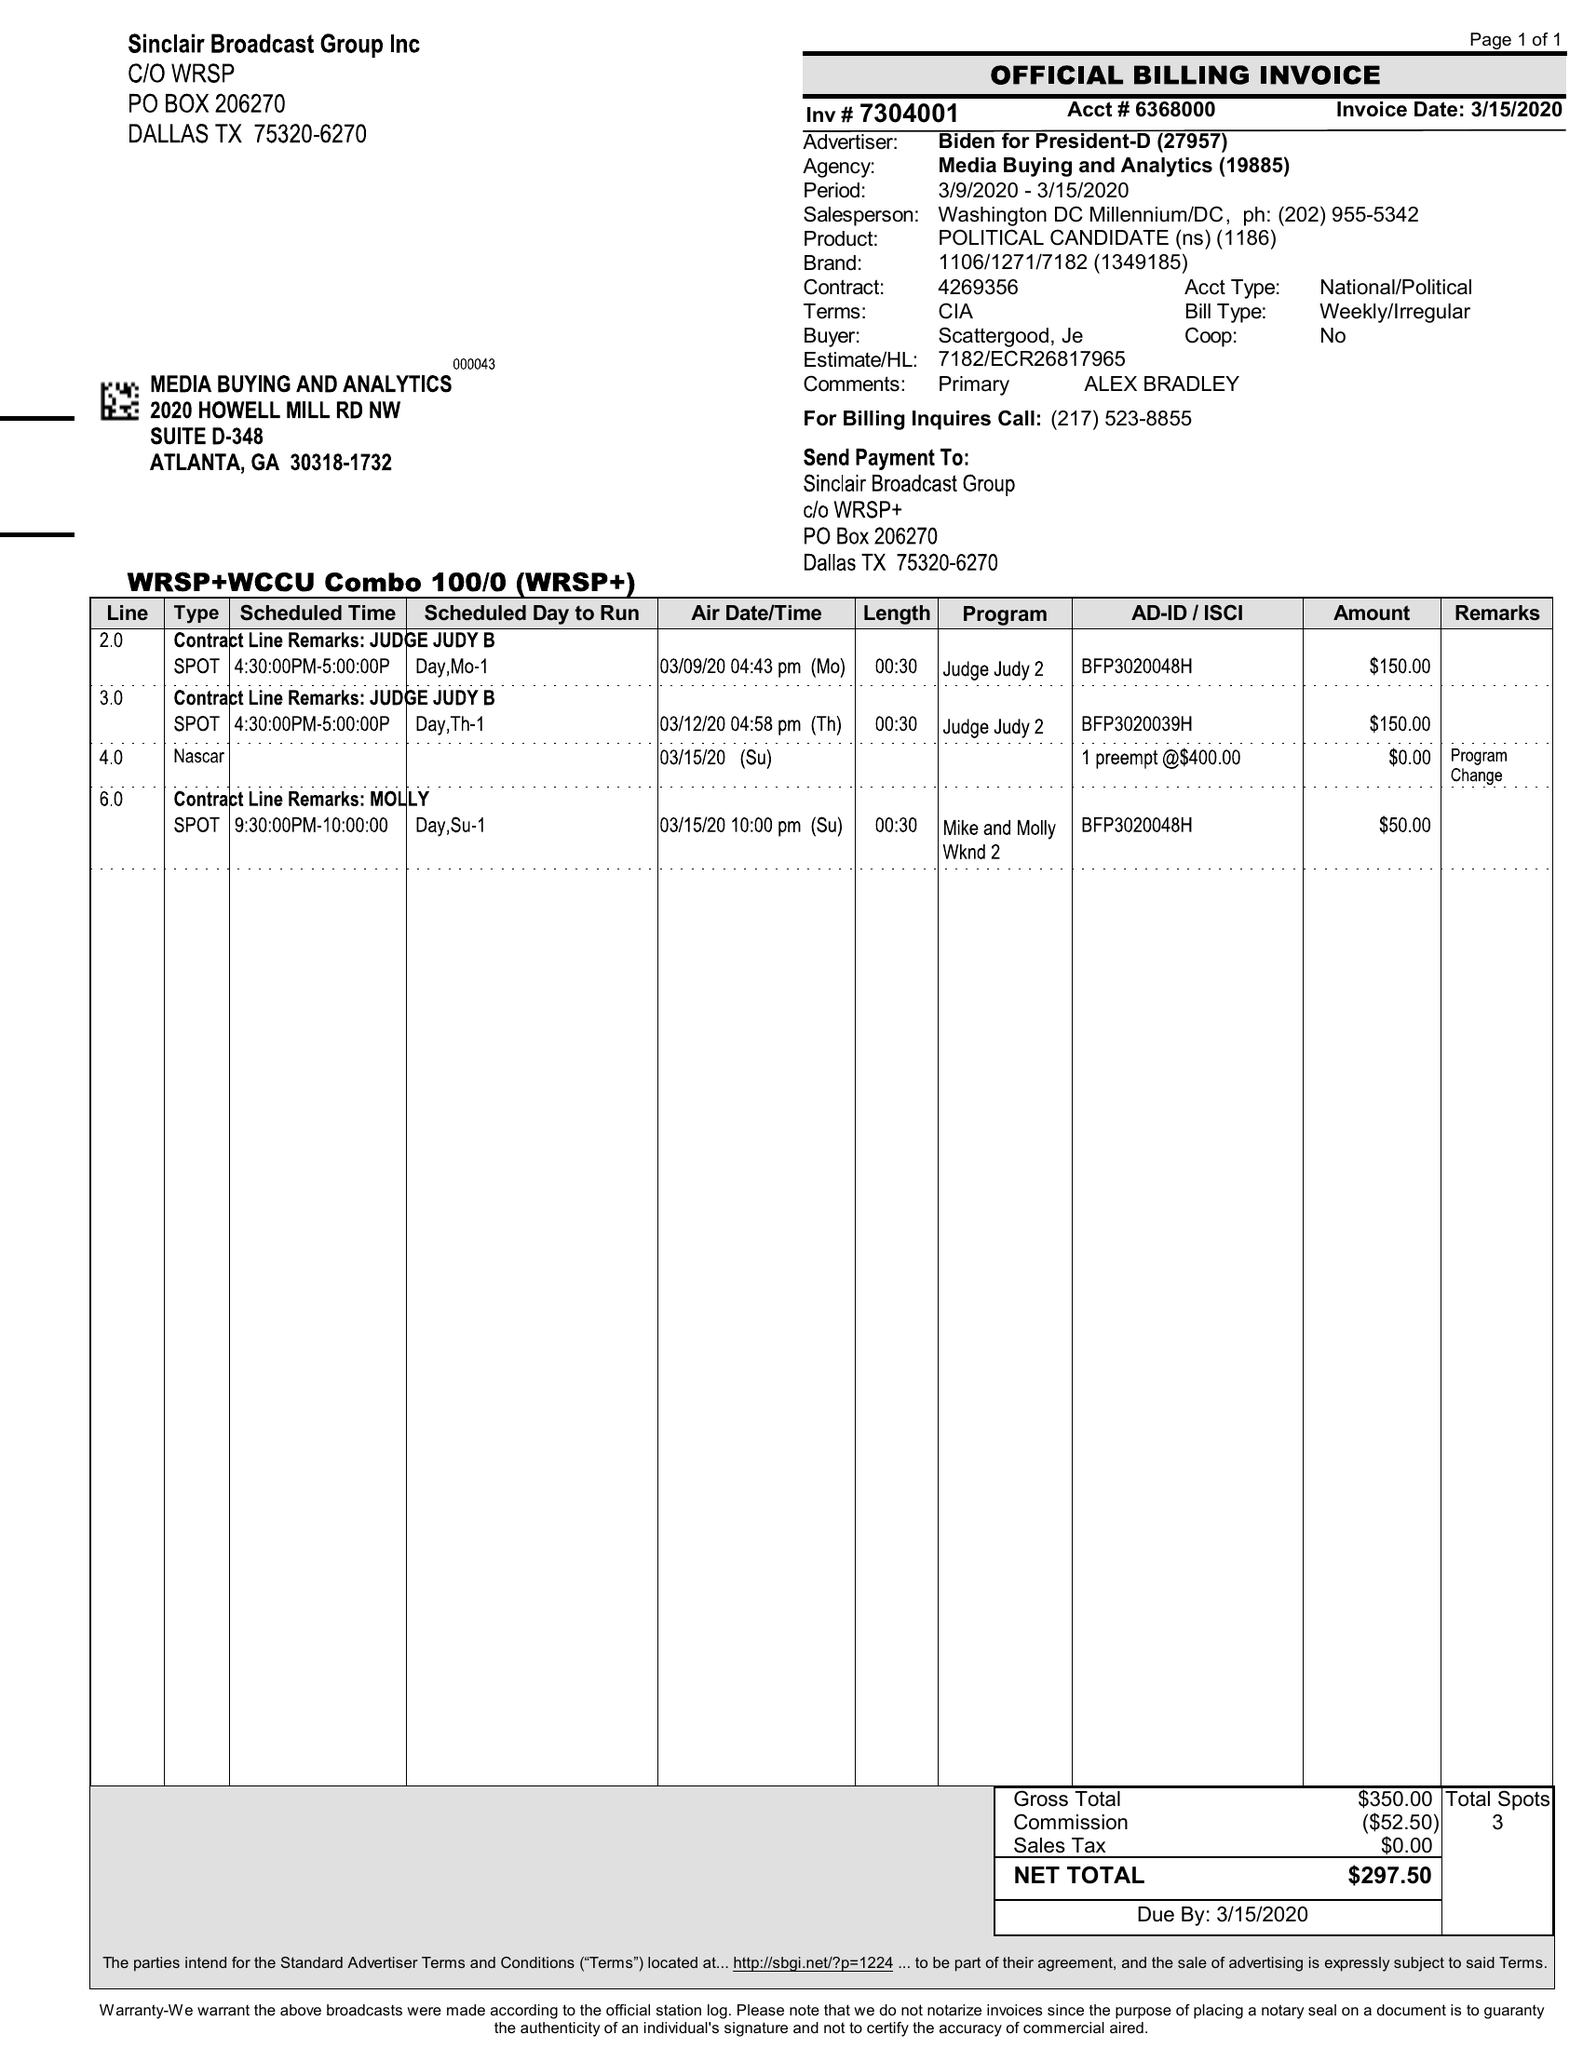What is the value for the flight_to?
Answer the question using a single word or phrase. 03/15/20 